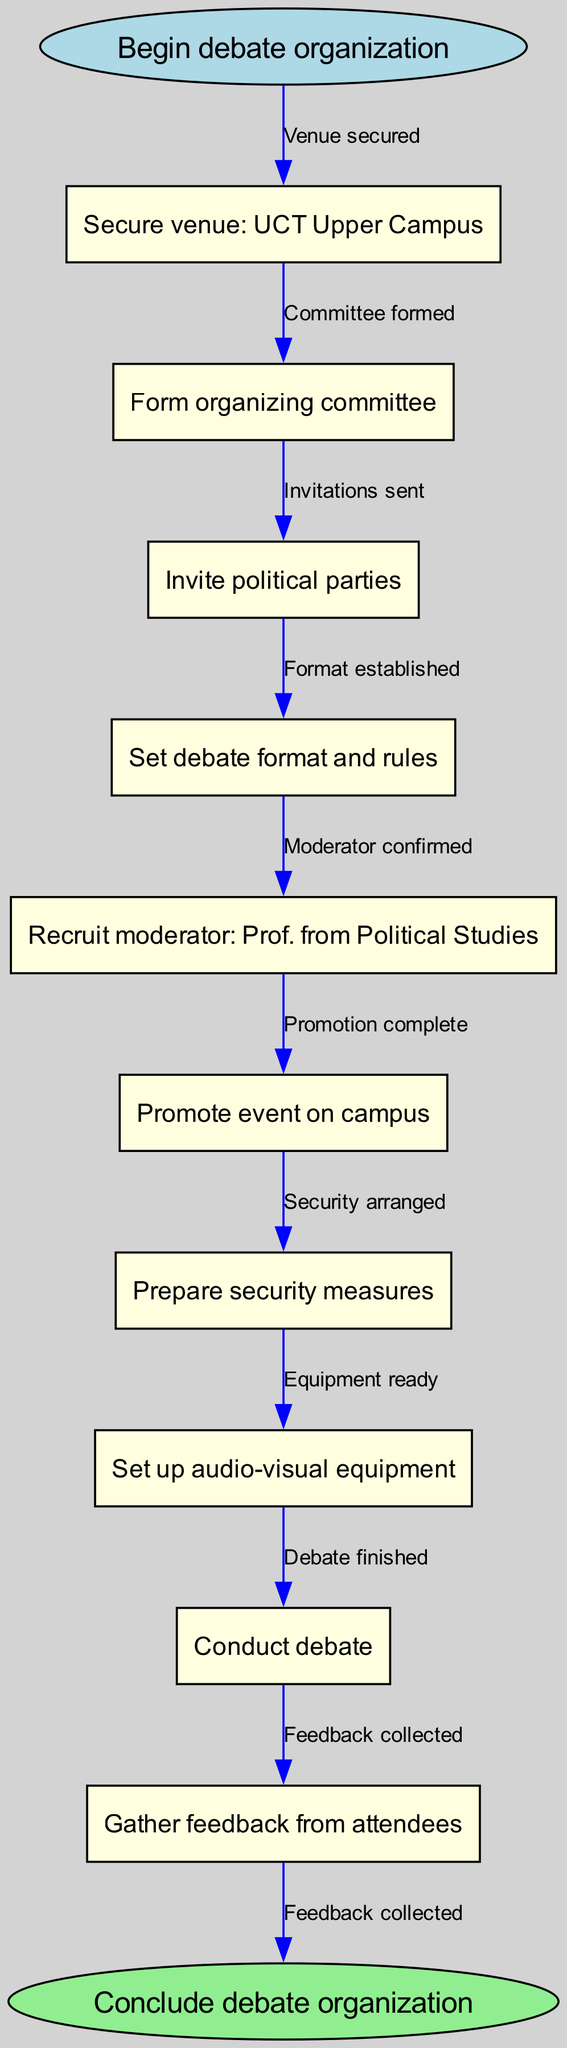What is the first step in the debate organization process? The first step is represented by the starting node in the diagram, which indicates "Begin debate organization."
Answer: Begin debate organization How many nodes are present in the diagram? To determine the number of nodes, we count the nodes listed, including the start and end nodes: 1 (start) + 9 (intermediate) + 1 (end) = 11 nodes in total.
Answer: 11 What is the last action taken before concluding the debate organization? The last action before concluding is represented by the final node, which states "Gather feedback from attendees."
Answer: Gather feedback from attendees Which node is connected to "Promote event on campus"? The node "Promote event on campus" is connected to the previous node "Recruit moderator: Prof. from Political Studies," showing the flow of actions.
Answer: Recruit moderator: Prof. from Political Studies What does the edge connecting "Conduct debate" to the end node signify? The edge signifies that after the debate is conducted, it leads directly to the conclusion of the debate organization process; it encapsulates the completion of all prior tasks.
Answer: Debate finished What is the significance of the arrow from "Secure venue: UCT Upper Campus" to "Form organizing committee"? The arrow signifies a sequential relationship indicating that securing the venue must be completed before forming the organizing committee, emphasizing the logical order of actions.
Answer: Committee formed How many edges are illustrated in the flowchart? We can count the edges by recognizing that each action connects to another: 10 actions lead sequentially from start to end, resulting in 10 edges total.
Answer: 10 What format is established before inviting political parties? The node that represents the established format is "Set debate format and rules," which must occur first before the next action of inviting parties can take place.
Answer: Set debate format and rules Which node directly follows the "Set up audio-visual equipment"? Following the "Set up audio-visual equipment," the next node is "Conduct debate," indicating the sequence of actions necessary for the event.
Answer: Conduct debate 